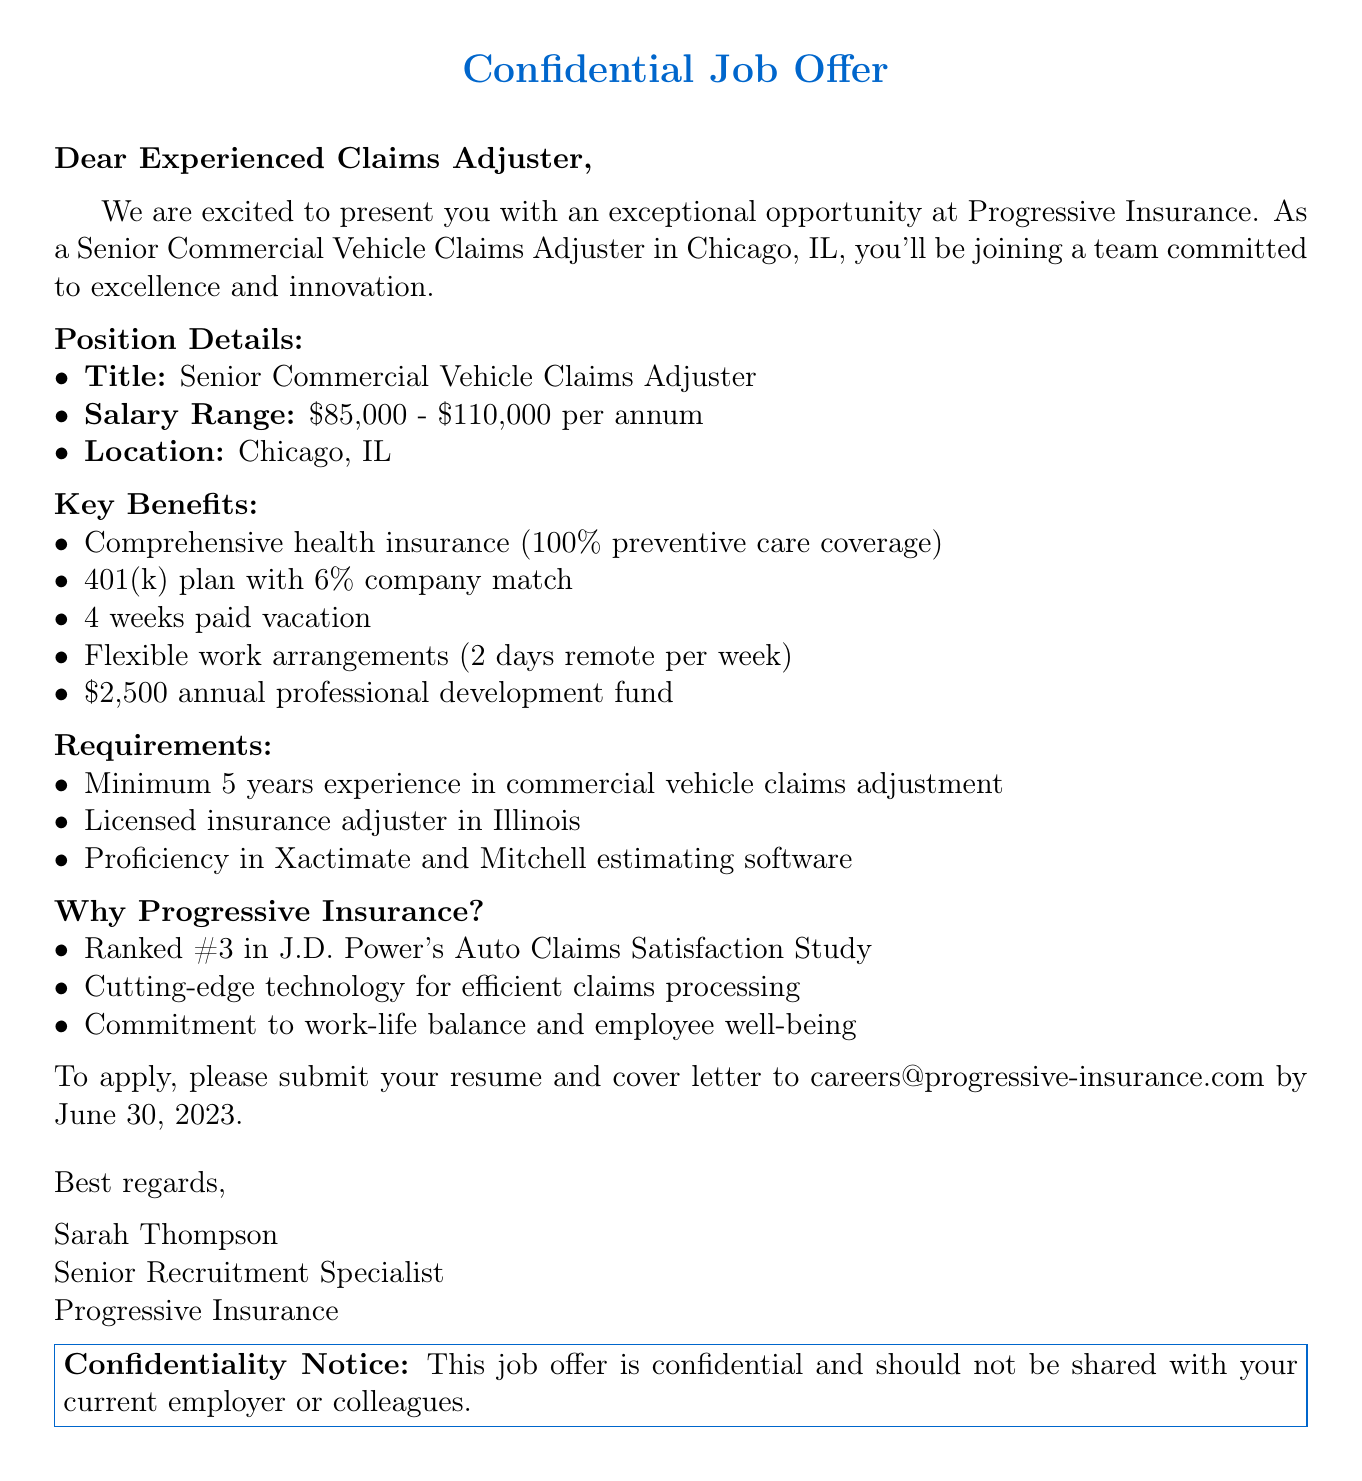What is the name of the sender? The sender's name is mentioned at the beginning of the document as Sarah Thompson.
Answer: Sarah Thompson What is the job title offered? The job title is given in the position details section of the document.
Answer: Senior Commercial Vehicle Claims Adjuster What is the salary range for this position? The salary range is explicitly stated in the position details section.
Answer: $85,000 - $110,000 per annum What is the application deadline? The application deadline is provided in the application process section of the document.
Answer: June 30, 2023 What is one of the key benefits mentioned? The key benefits segment includes several benefits; one specific benefit is requested.
Answer: Comprehensive health insurance with 100% coverage for preventive care What is required in terms of experience? The requirements section states the minimum experience needed.
Answer: Minimum 5 years experience in commercial vehicle claims adjustment What is the location of the job? The job's location is mentioned in the position details.
Answer: Chicago, IL Why might a candidate consider applying? This can be inferred from the company highlights that describe the organization positively.
Answer: Ranked #3 in J.D. Power's Auto Claims Satisfaction Study What should candidates submit to apply? The application process outlines what needs to be submitted.
Answer: Resume and cover letter What is the confidentiality clause about? The confidentiality clause warns against sharing the job offer details.
Answer: This job offer is confidential and should not be shared with your current employer or colleagues 